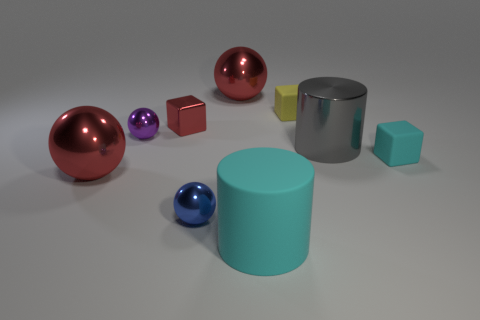Add 1 purple objects. How many objects exist? 10 Subtract all cylinders. How many objects are left? 7 Add 3 small purple cubes. How many small purple cubes exist? 3 Subtract 0 blue blocks. How many objects are left? 9 Subtract all small yellow matte objects. Subtract all big rubber cylinders. How many objects are left? 7 Add 9 tiny cyan objects. How many tiny cyan objects are left? 10 